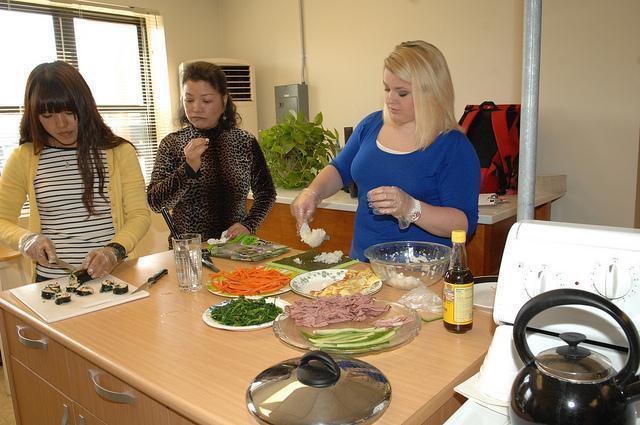How many people are there?
Give a very brief answer. 3. How many ovens are there?
Give a very brief answer. 1. How many cars are there with yellow color?
Give a very brief answer. 0. 